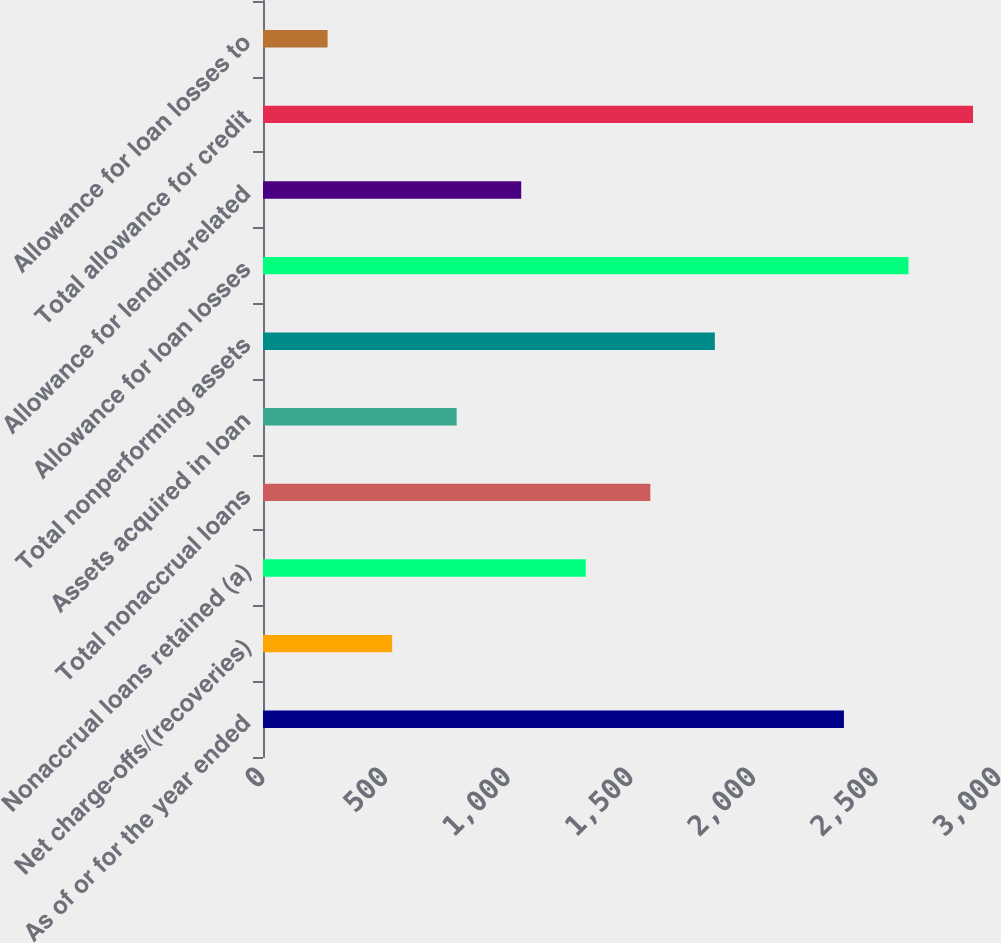Convert chart. <chart><loc_0><loc_0><loc_500><loc_500><bar_chart><fcel>As of or for the year ended<fcel>Net charge-offs/(recoveries)<fcel>Nonaccrual loans retained (a)<fcel>Total nonaccrual loans<fcel>Assets acquired in loan<fcel>Total nonperforming assets<fcel>Allowance for loan losses<fcel>Allowance for lending-related<fcel>Total allowance for credit<fcel>Allowance for loan losses to<nl><fcel>2367.94<fcel>526.38<fcel>1315.62<fcel>1578.7<fcel>789.46<fcel>1841.78<fcel>2631.02<fcel>1052.54<fcel>2894.1<fcel>263.3<nl></chart> 